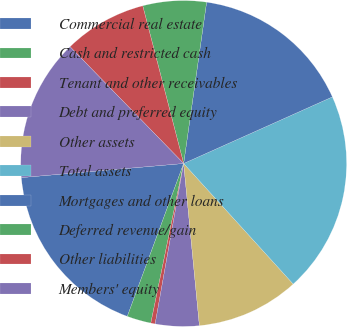Convert chart. <chart><loc_0><loc_0><loc_500><loc_500><pie_chart><fcel>Commercial real estate<fcel>Cash and restricted cash<fcel>Tenant and other receivables<fcel>Debt and preferred equity<fcel>Other assets<fcel>Total assets<fcel>Mortgages and other loans<fcel>Deferred revenue/gain<fcel>Other liabilities<fcel>Members' equity<nl><fcel>18.0%<fcel>2.39%<fcel>0.43%<fcel>4.34%<fcel>10.2%<fcel>19.96%<fcel>16.05%<fcel>6.29%<fcel>8.24%<fcel>14.1%<nl></chart> 